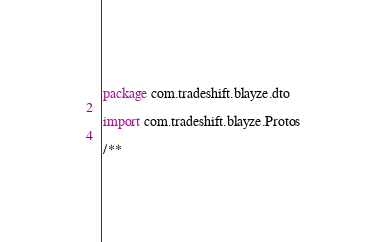Convert code to text. <code><loc_0><loc_0><loc_500><loc_500><_Kotlin_>package com.tradeshift.blayze.dto

import com.tradeshift.blayze.Protos

/**</code> 